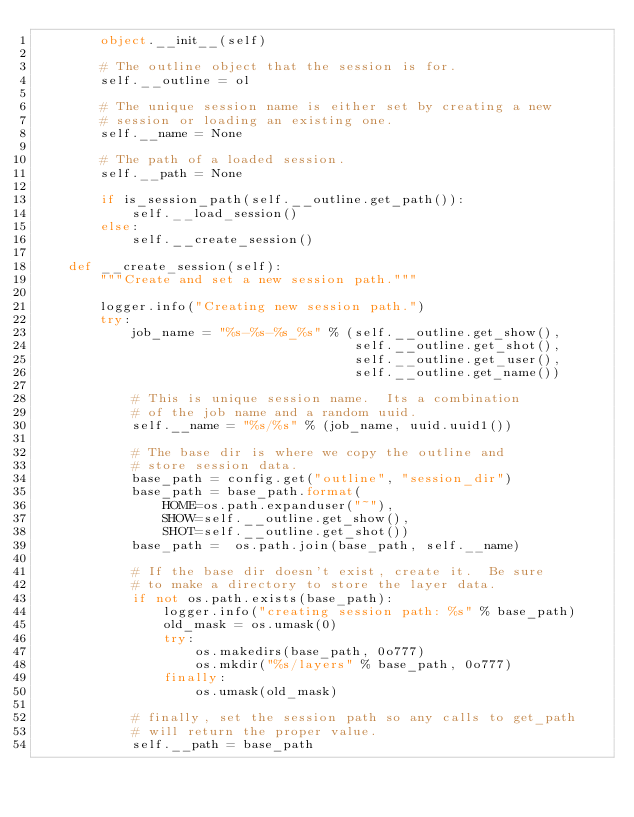<code> <loc_0><loc_0><loc_500><loc_500><_Python_>        object.__init__(self)

        # The outline object that the session is for.
        self.__outline = ol

        # The unique session name is either set by creating a new
        # session or loading an existing one.
        self.__name = None

        # The path of a loaded session.
        self.__path = None

        if is_session_path(self.__outline.get_path()):
            self.__load_session()
        else:
            self.__create_session()

    def __create_session(self):
        """Create and set a new session path."""

        logger.info("Creating new session path.")
        try:
            job_name = "%s-%s-%s_%s" % (self.__outline.get_show(),
                                        self.__outline.get_shot(),
                                        self.__outline.get_user(),
                                        self.__outline.get_name())

            # This is unique session name.  Its a combination
            # of the job name and a random uuid.
            self.__name = "%s/%s" % (job_name, uuid.uuid1())

            # The base dir is where we copy the outline and
            # store session data.
            base_path = config.get("outline", "session_dir")
            base_path = base_path.format(
                HOME=os.path.expanduser("~"),
                SHOW=self.__outline.get_show(),
                SHOT=self.__outline.get_shot())
            base_path =  os.path.join(base_path, self.__name)

            # If the base dir doesn't exist, create it.  Be sure
            # to make a directory to store the layer data.
            if not os.path.exists(base_path):
                logger.info("creating session path: %s" % base_path)
                old_mask = os.umask(0)
                try:
                    os.makedirs(base_path, 0o777)
                    os.mkdir("%s/layers" % base_path, 0o777)
                finally:
                    os.umask(old_mask)

            # finally, set the session path so any calls to get_path
            # will return the proper value.
            self.__path = base_path
</code> 